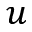<formula> <loc_0><loc_0><loc_500><loc_500>u</formula> 